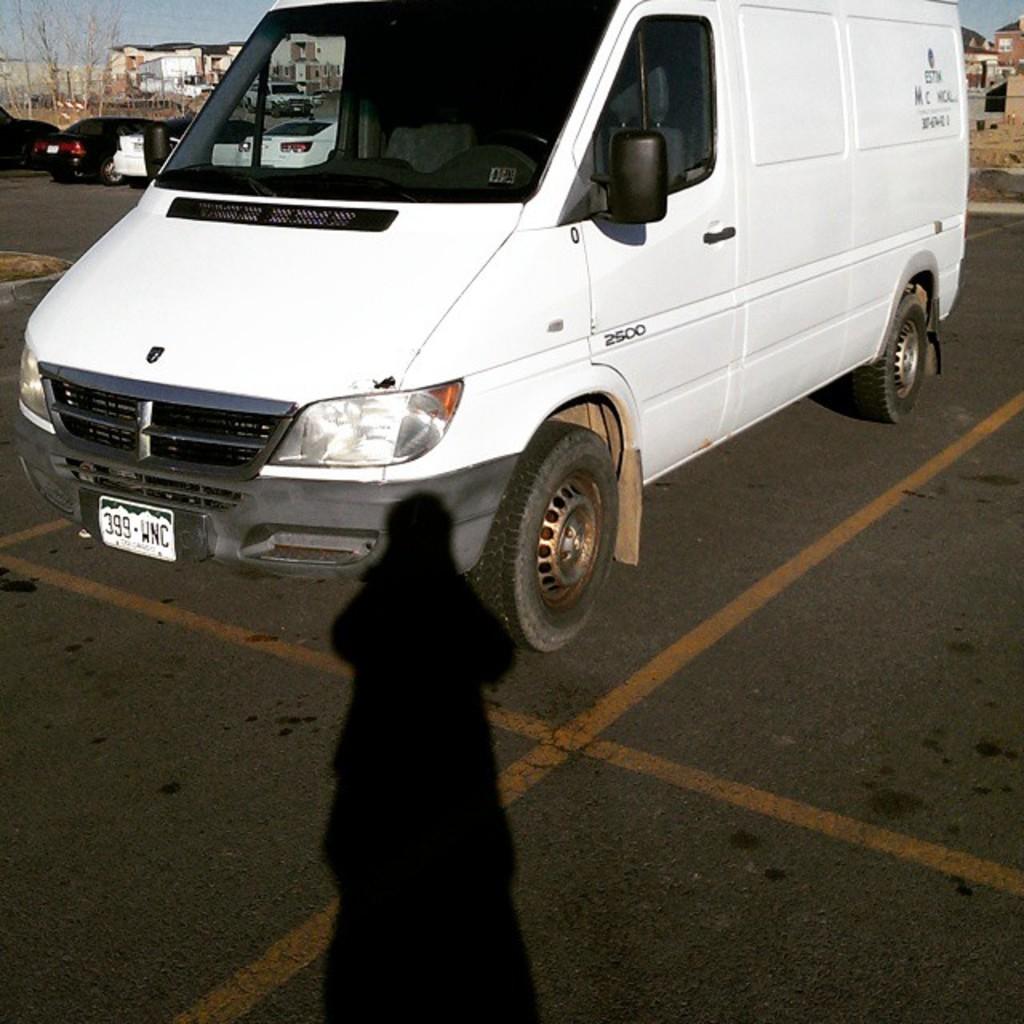What does the license plate say?
Your answer should be compact. 399 wnc. What is the model number of this van series?
Your answer should be compact. 2500. 